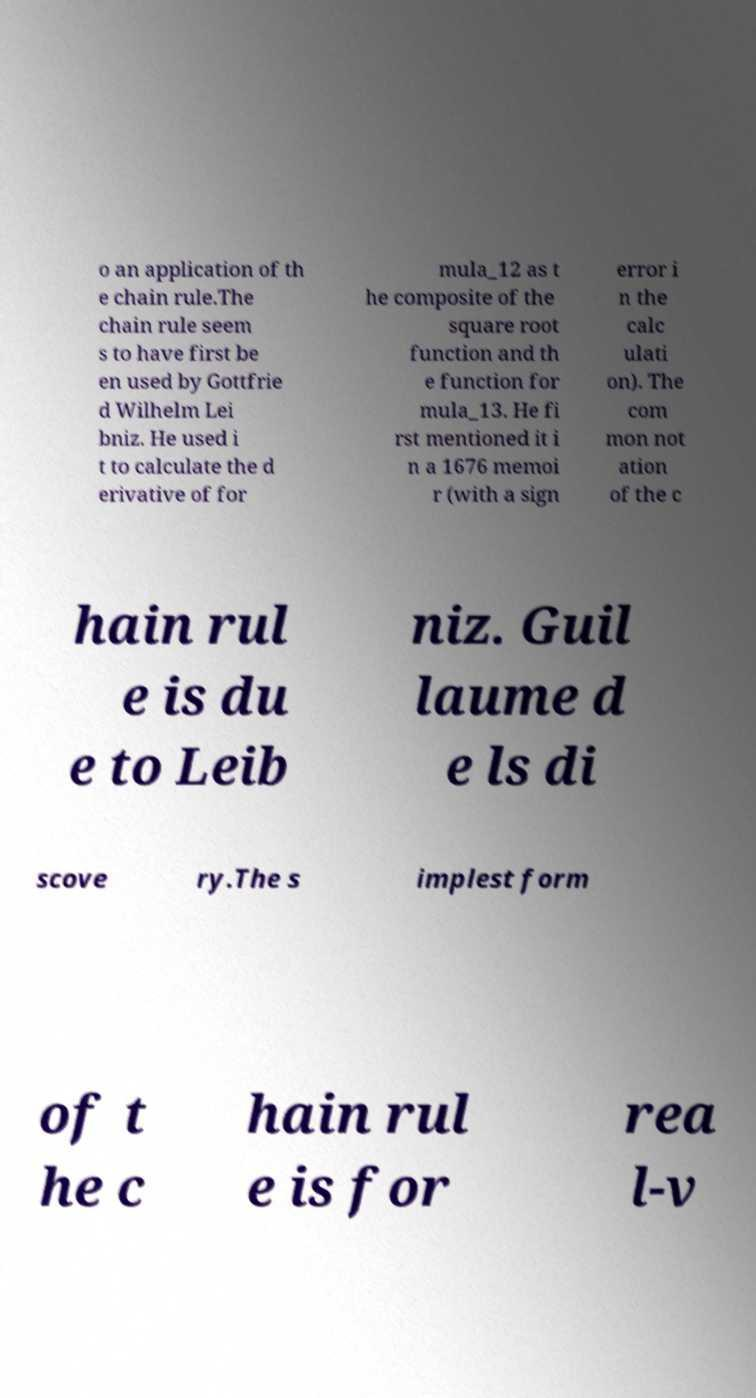Can you accurately transcribe the text from the provided image for me? o an application of th e chain rule.The chain rule seem s to have first be en used by Gottfrie d Wilhelm Lei bniz. He used i t to calculate the d erivative of for mula_12 as t he composite of the square root function and th e function for mula_13. He fi rst mentioned it i n a 1676 memoi r (with a sign error i n the calc ulati on). The com mon not ation of the c hain rul e is du e to Leib niz. Guil laume d e ls di scove ry.The s implest form of t he c hain rul e is for rea l-v 